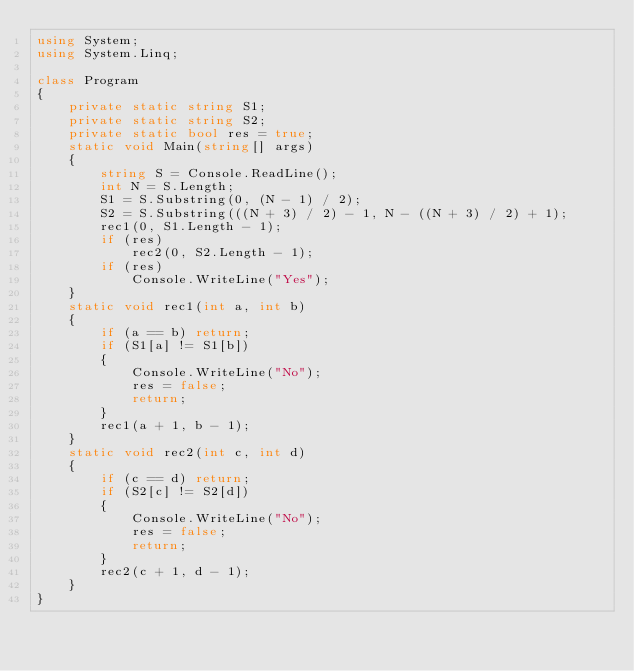<code> <loc_0><loc_0><loc_500><loc_500><_C#_>using System;
using System.Linq;

class Program
{
    private static string S1;
    private static string S2;
    private static bool res = true;
    static void Main(string[] args)
    {
        string S = Console.ReadLine();
        int N = S.Length;
        S1 = S.Substring(0, (N - 1) / 2);
        S2 = S.Substring(((N + 3) / 2) - 1, N - ((N + 3) / 2) + 1);
        rec1(0, S1.Length - 1);
        if (res)
            rec2(0, S2.Length - 1);
        if (res)
            Console.WriteLine("Yes");
    }
    static void rec1(int a, int b)
    {
        if (a == b) return;
        if (S1[a] != S1[b])
        {
            Console.WriteLine("No");
            res = false;
            return;
        }
        rec1(a + 1, b - 1);
    }
    static void rec2(int c, int d)
    {
        if (c == d) return;
        if (S2[c] != S2[d])
        {
            Console.WriteLine("No");
            res = false;
            return;
        }
        rec2(c + 1, d - 1);
    }
}</code> 